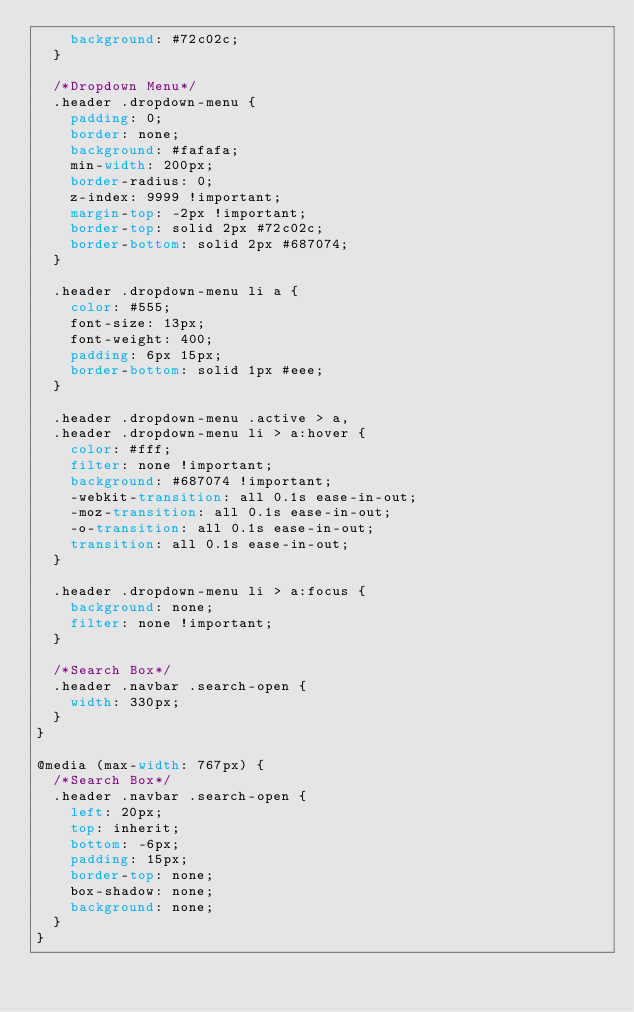Convert code to text. <code><loc_0><loc_0><loc_500><loc_500><_CSS_>		background: #72c02c;		
	}

	/*Dropdown Menu*/
	.header .dropdown-menu { 
		padding: 0;
		border: none;
		background: #fafafa;
		min-width: 200px;
		border-radius: 0; 
		z-index: 9999 !important;
		margin-top: -2px !important;
		border-top: solid 2px #72c02c; 
		border-bottom: solid 2px #687074; 
	}

	.header .dropdown-menu li a { 
		color: #555; 
		font-size: 13px; 
		font-weight: 400; 
		padding: 6px 15px; 
		border-bottom: solid 1px #eee;
	}

	.header .dropdown-menu .active > a,
	.header .dropdown-menu li > a:hover {
		color: #fff;
		filter: none !important;
		background: #687074 !important;
		-webkit-transition: all 0.1s ease-in-out;
		-moz-transition: all 0.1s ease-in-out;
		-o-transition: all 0.1s ease-in-out;
		transition: all 0.1s ease-in-out;
	}

	.header .dropdown-menu li > a:focus {
		background: none;
		filter: none !important;
	}

	/*Search Box*/
	.header .navbar .search-open {
		width: 330px;
	}	
}

@media (max-width: 767px) {
	/*Search Box*/
	.header .navbar .search-open {
		left: 20px; 
		top: inherit;
		bottom: -6px; 
		padding: 15px;
		border-top: none;
		box-shadow: none;
		background: none; 
	}	
}</code> 